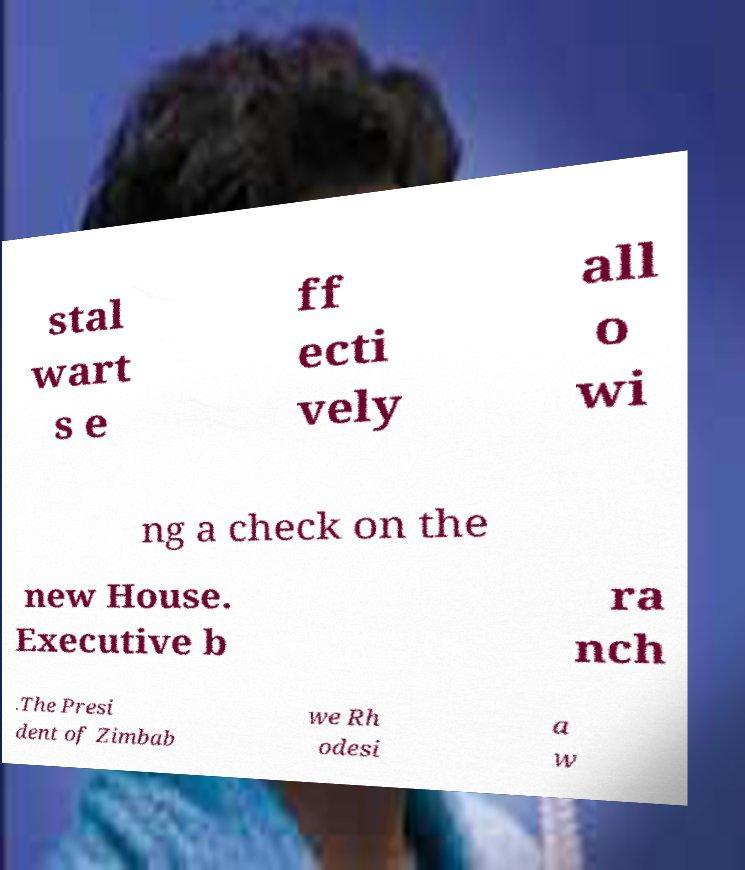Could you assist in decoding the text presented in this image and type it out clearly? stal wart s e ff ecti vely all o wi ng a check on the new House. Executive b ra nch .The Presi dent of Zimbab we Rh odesi a w 